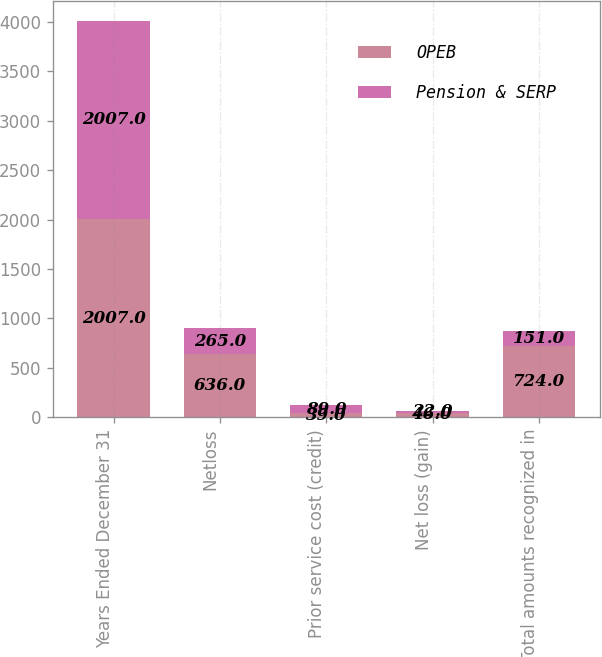Convert chart to OTSL. <chart><loc_0><loc_0><loc_500><loc_500><stacked_bar_chart><ecel><fcel>Years Ended December 31<fcel>Netloss<fcel>Prior service cost (credit)<fcel>Net loss (gain)<fcel>Total amounts recognized in<nl><fcel>OPEB<fcel>2007<fcel>636<fcel>39<fcel>46<fcel>724<nl><fcel>Pension & SERP<fcel>2007<fcel>265<fcel>89<fcel>22<fcel>151<nl></chart> 